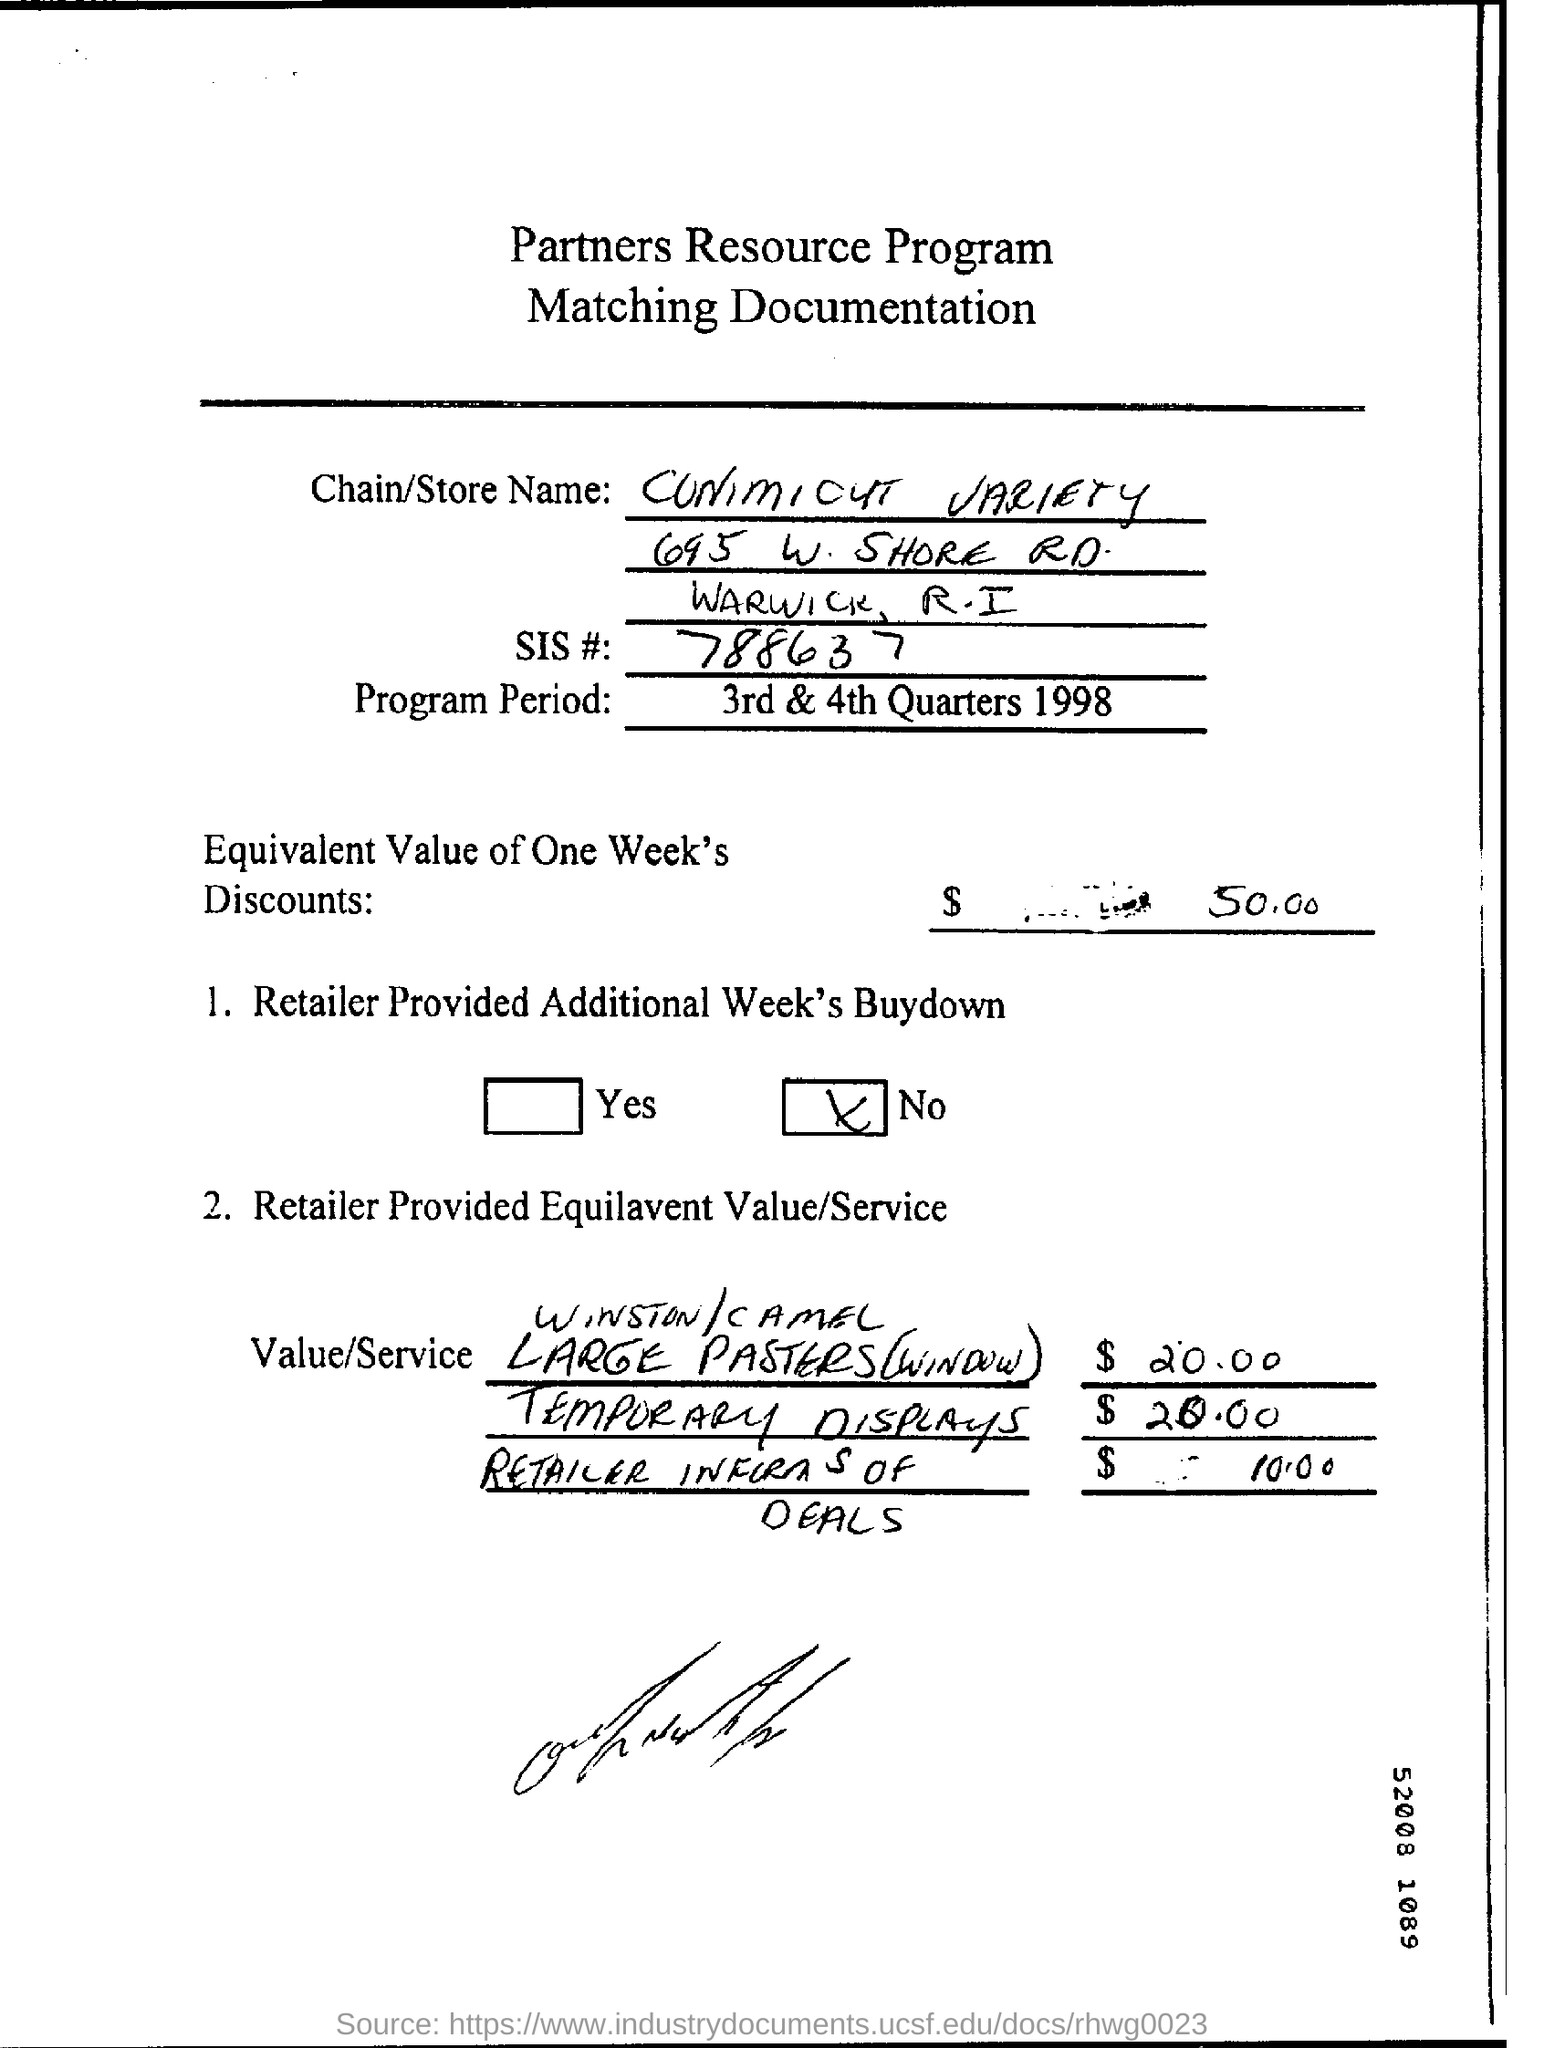What is the Title of the document ?
Provide a succinct answer. Partners Resource Program. What is the SIS Number ?
Keep it short and to the point. 788637. 